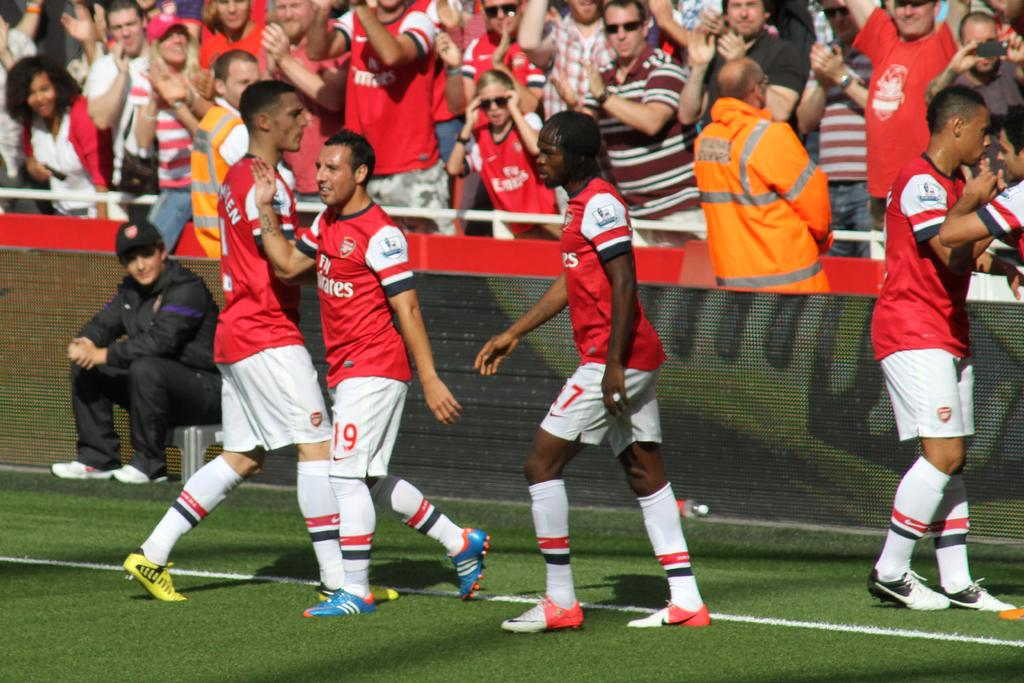Provide a one-sentence caption for the provided image. a soccer team with one of the players wearing the number 19. 